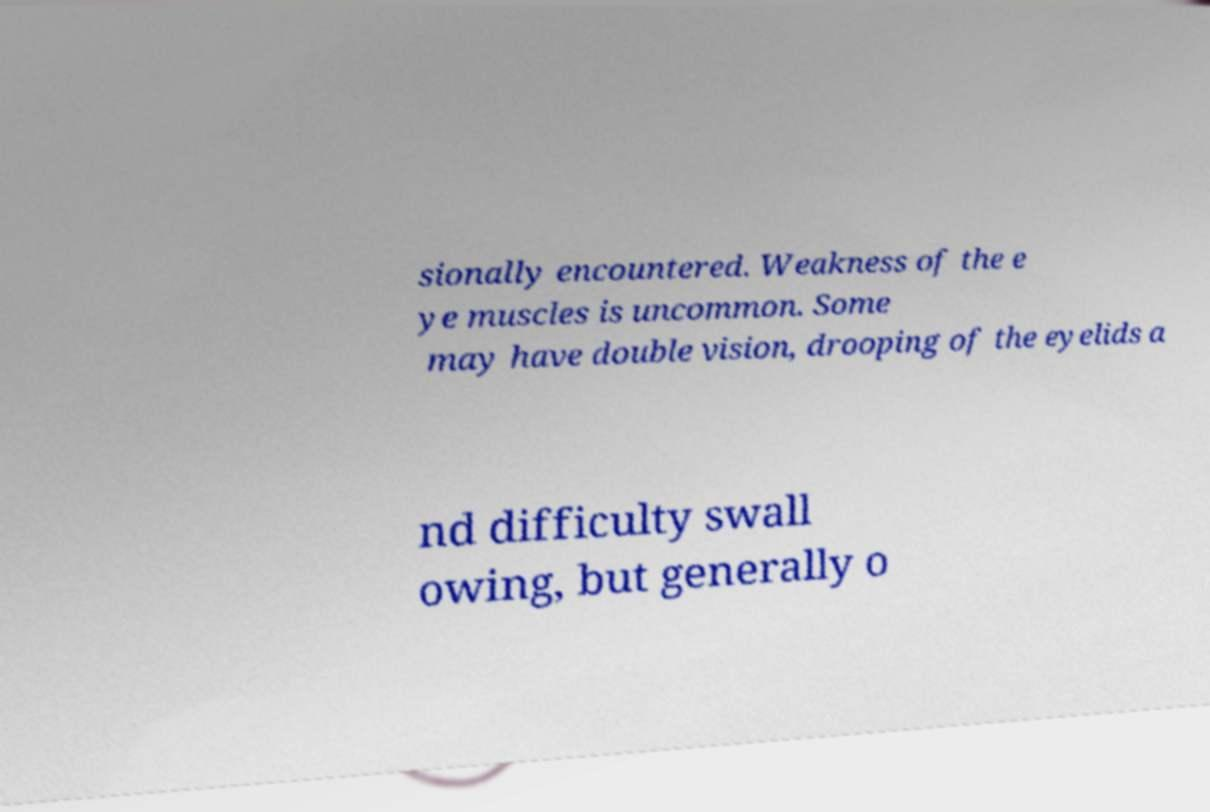Could you assist in decoding the text presented in this image and type it out clearly? sionally encountered. Weakness of the e ye muscles is uncommon. Some may have double vision, drooping of the eyelids a nd difficulty swall owing, but generally o 